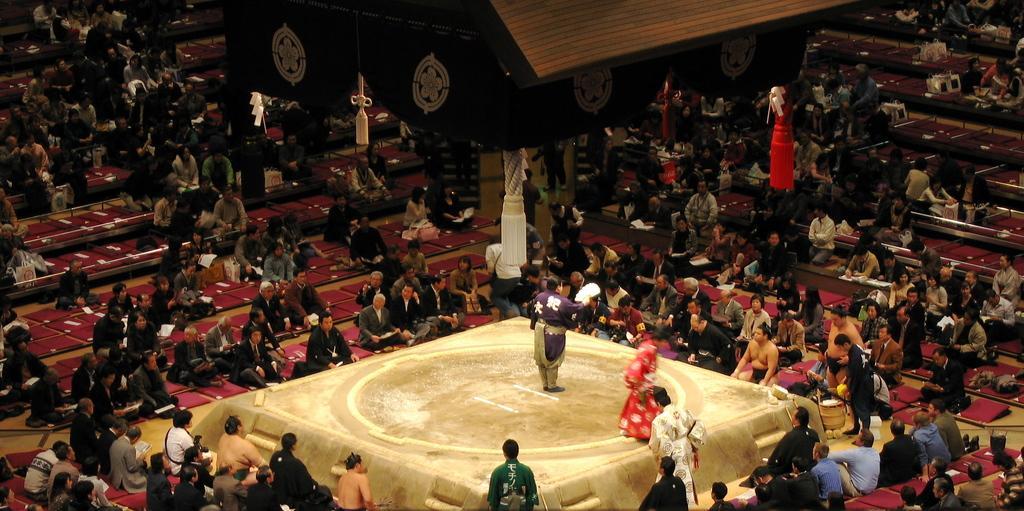How would you summarize this image in a sentence or two? This image consists of many people sitting on the ground. In the middle, it looks like a dais. On which we can see two persons. At the top, it looks like a tent. 